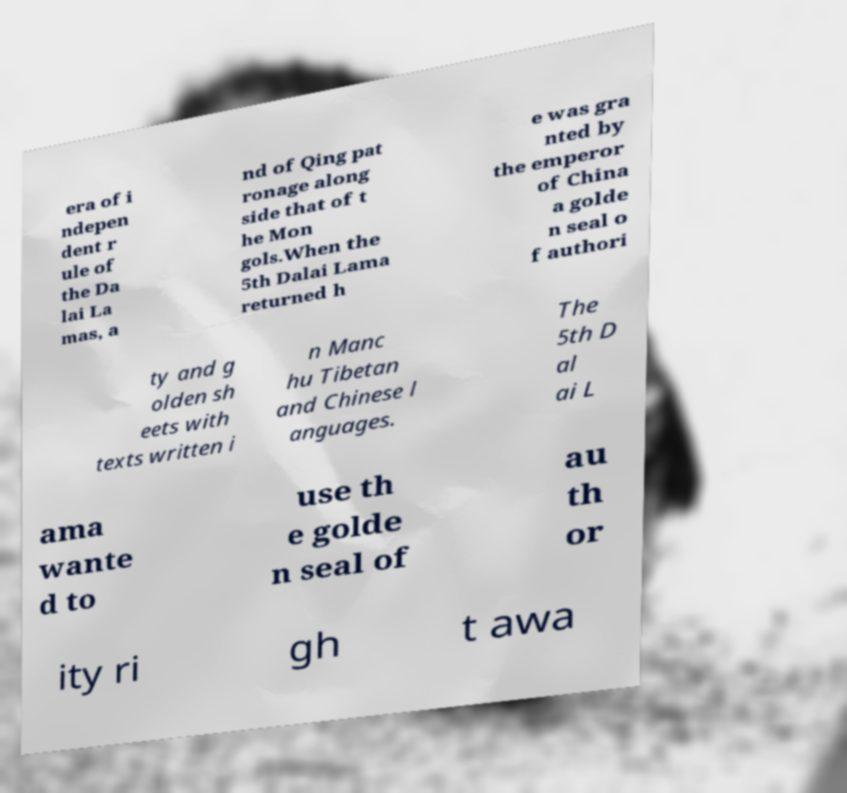What messages or text are displayed in this image? I need them in a readable, typed format. era of i ndepen dent r ule of the Da lai La mas, a nd of Qing pat ronage along side that of t he Mon gols.When the 5th Dalai Lama returned h e was gra nted by the emperor of China a golde n seal o f authori ty and g olden sh eets with texts written i n Manc hu Tibetan and Chinese l anguages. The 5th D al ai L ama wante d to use th e golde n seal of au th or ity ri gh t awa 